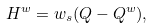<formula> <loc_0><loc_0><loc_500><loc_500>H ^ { w } = w _ { s } ( { Q } - { Q } ^ { w } ) ,</formula> 